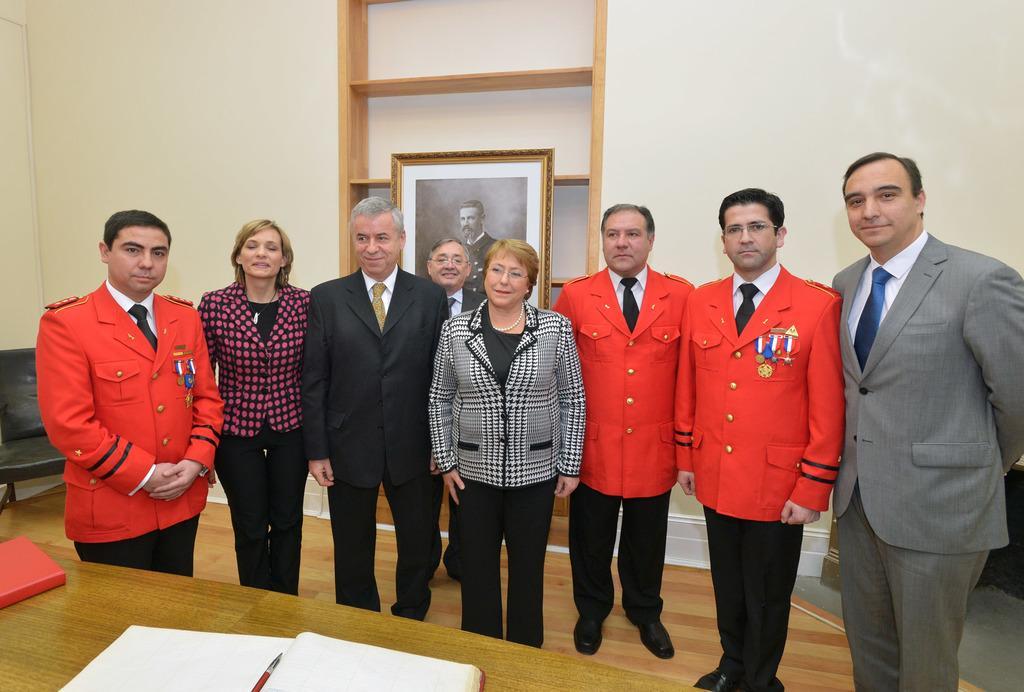Please provide a concise description of this image. There are many people standing. Some are wearing uniform with badges. In front of them there is a table. On that there are books. On the book there is a pen. In the back there is a wall with cupboard. Near to that there is a photo frame. 